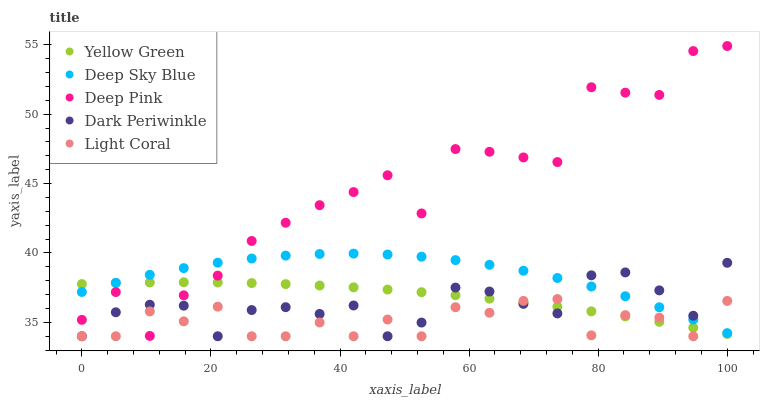Does Light Coral have the minimum area under the curve?
Answer yes or no. Yes. Does Deep Pink have the maximum area under the curve?
Answer yes or no. Yes. Does Yellow Green have the minimum area under the curve?
Answer yes or no. No. Does Yellow Green have the maximum area under the curve?
Answer yes or no. No. Is Yellow Green the smoothest?
Answer yes or no. Yes. Is Deep Pink the roughest?
Answer yes or no. Yes. Is Deep Pink the smoothest?
Answer yes or no. No. Is Yellow Green the roughest?
Answer yes or no. No. Does Light Coral have the lowest value?
Answer yes or no. Yes. Does Deep Pink have the lowest value?
Answer yes or no. No. Does Deep Pink have the highest value?
Answer yes or no. Yes. Does Yellow Green have the highest value?
Answer yes or no. No. Does Dark Periwinkle intersect Yellow Green?
Answer yes or no. Yes. Is Dark Periwinkle less than Yellow Green?
Answer yes or no. No. Is Dark Periwinkle greater than Yellow Green?
Answer yes or no. No. 